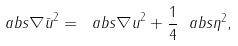<formula> <loc_0><loc_0><loc_500><loc_500>\ a b s { \nabla \bar { u } } ^ { 2 } = \ a b s { \nabla u } ^ { 2 } + \frac { 1 } { 4 } \ a b s { \eta } ^ { 2 } ,</formula> 